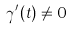<formula> <loc_0><loc_0><loc_500><loc_500>\gamma ^ { \prime } ( t ) \ne 0</formula> 